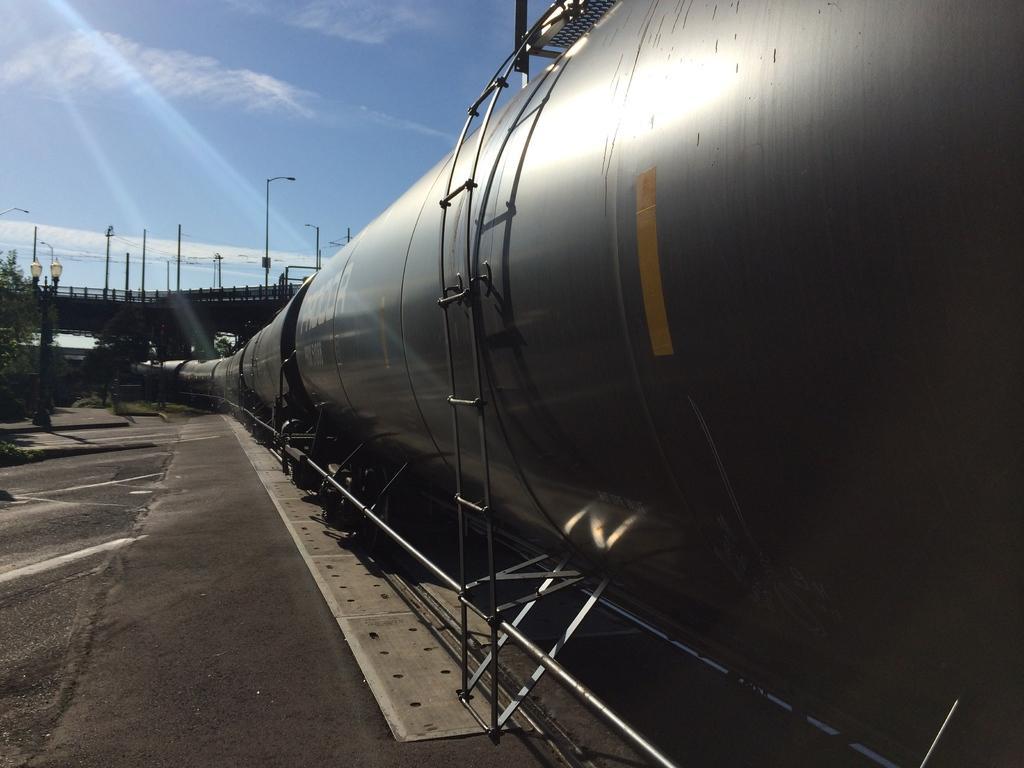Please provide a concise description of this image. In the picture we can see a train with oil tankers and some equipment to it and besides, we can see a path and in the background, we can see some bridge and some poles with a light to it and we can also see a sky with clouds. 